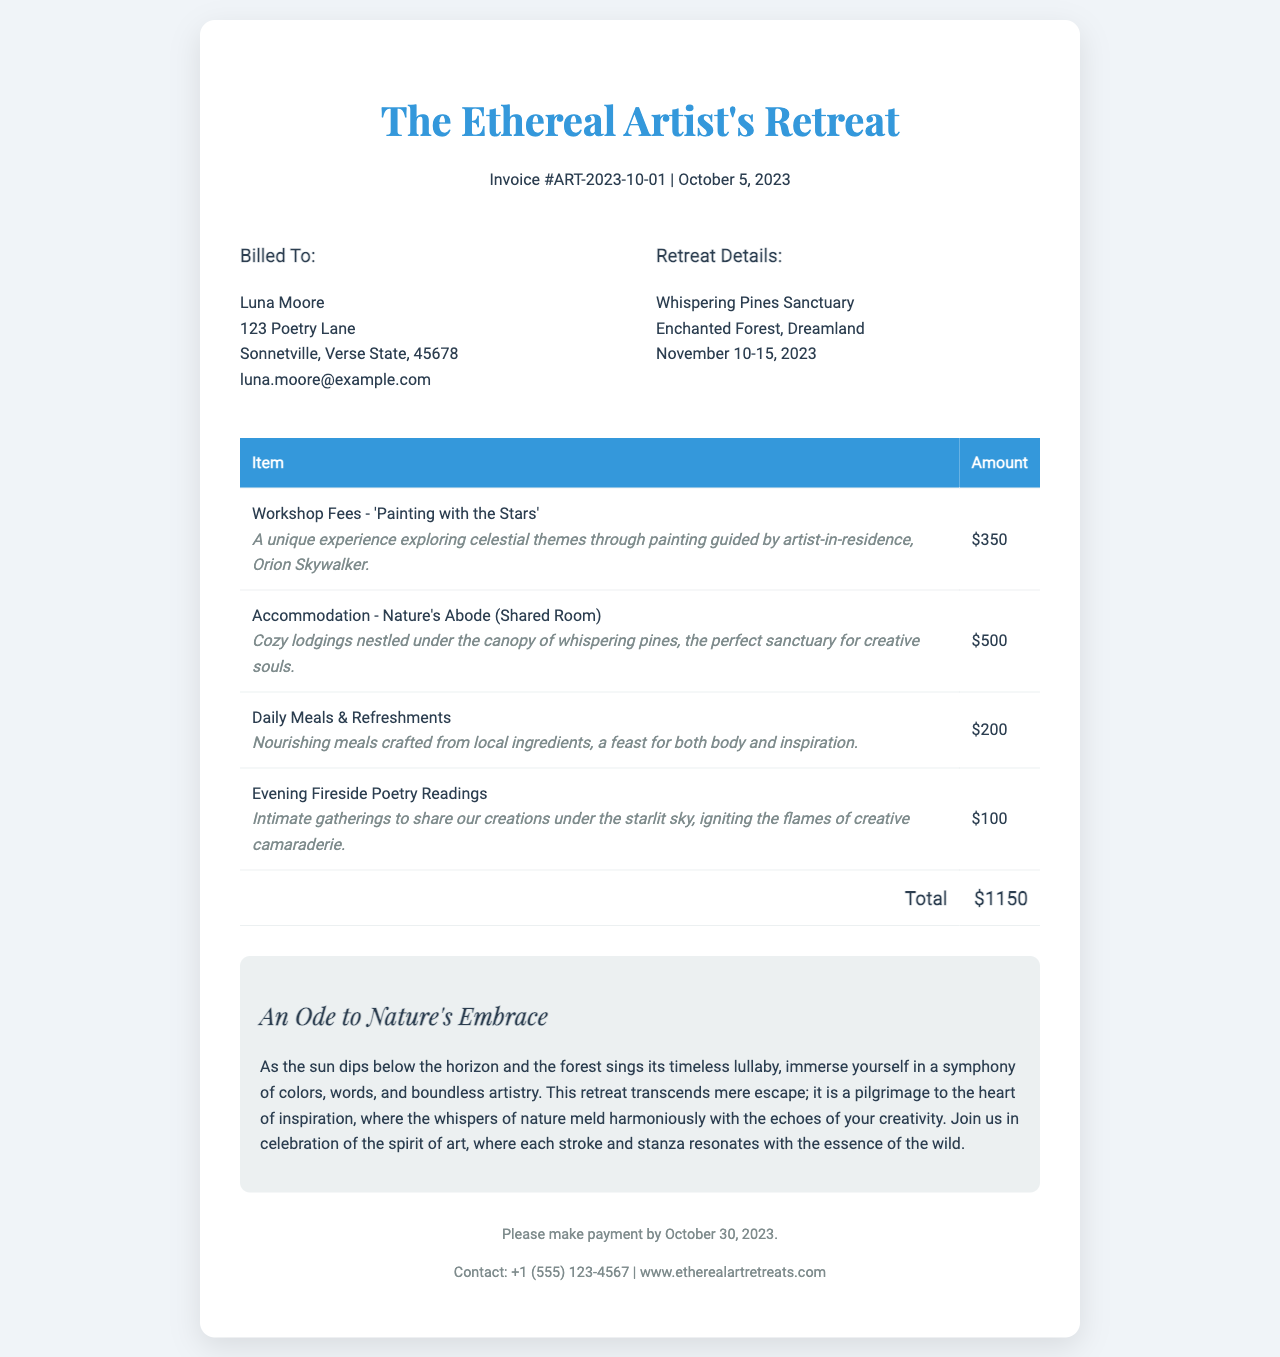What is the total amount due? The total amount due is clearly stated in the invoice footer, summarizing all the items listed.
Answer: $1150 Who is the artist-in-residence? The artist-in-residence for the workshop is mentioned in the item description for the workshop fees.
Answer: Orion Skywalker What are the dates of the retreat? The specific dates of the retreat are noted in the retreat details section.
Answer: November 10-15, 2023 What is the accommodation type? The type of accommodation is specified in the accommodation line of the invoice.
Answer: Shared Room How much are the daily meals and refreshments? The amount for daily meals and refreshments is listed in the invoice table under the respective item.
Answer: $200 What is the payment deadline? The deadline for making payment is included in the footer of the document.
Answer: October 30, 2023 What is the name of the retreat venue? The name of the retreat venue is located in the retreat details section of the invoice.
Answer: Whispering Pines Sanctuary How much is the workshop fee? The cost of the workshop is provided in the table, specifically next to the workshop item.
Answer: $350 What does the summary highlight about the retreat experience? The summary provides an evocative description of the retreat experience and its artistic influence.
Answer: An Ode to Nature's Embrace 